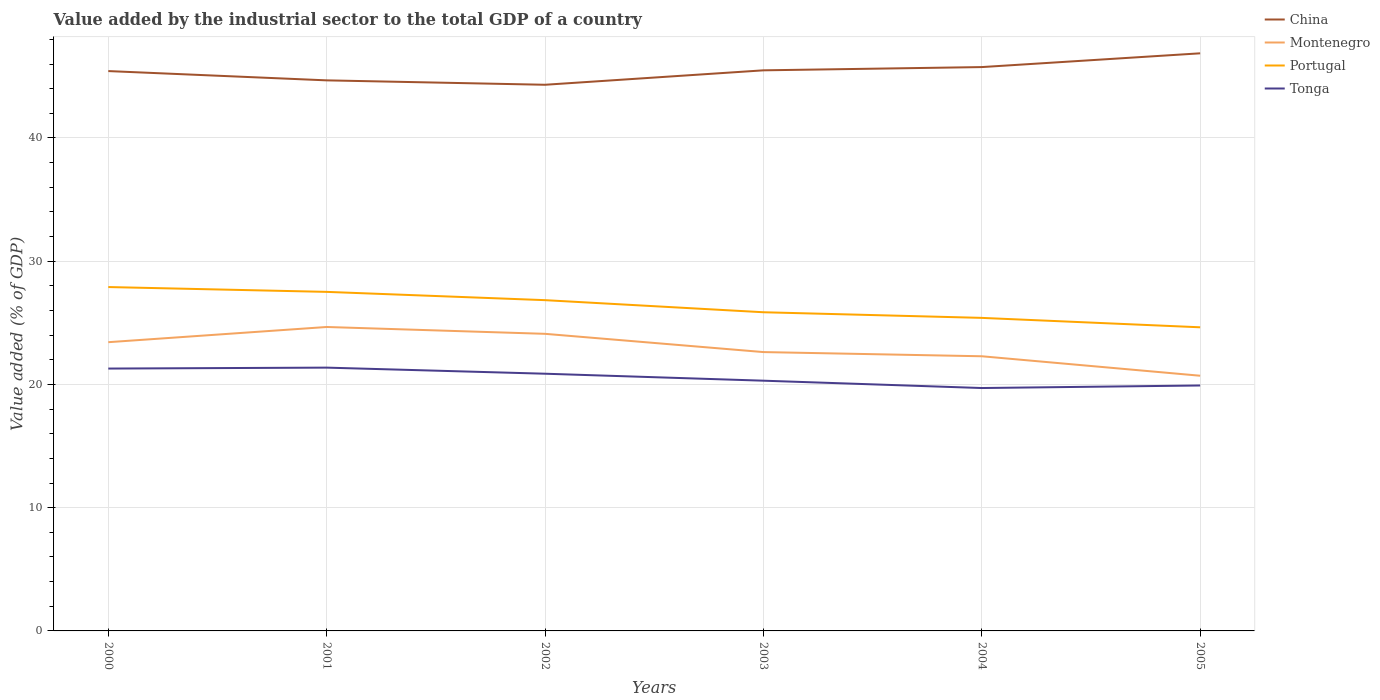Across all years, what is the maximum value added by the industrial sector to the total GDP in Montenegro?
Make the answer very short. 20.71. What is the total value added by the industrial sector to the total GDP in Montenegro in the graph?
Provide a succinct answer. 1.14. What is the difference between the highest and the second highest value added by the industrial sector to the total GDP in Portugal?
Your answer should be very brief. 3.27. What is the difference between the highest and the lowest value added by the industrial sector to the total GDP in Portugal?
Ensure brevity in your answer.  3. Is the value added by the industrial sector to the total GDP in China strictly greater than the value added by the industrial sector to the total GDP in Tonga over the years?
Give a very brief answer. No. How many years are there in the graph?
Your answer should be compact. 6. What is the difference between two consecutive major ticks on the Y-axis?
Provide a short and direct response. 10. Are the values on the major ticks of Y-axis written in scientific E-notation?
Offer a terse response. No. Does the graph contain any zero values?
Provide a short and direct response. No. How are the legend labels stacked?
Your response must be concise. Vertical. What is the title of the graph?
Offer a terse response. Value added by the industrial sector to the total GDP of a country. What is the label or title of the X-axis?
Make the answer very short. Years. What is the label or title of the Y-axis?
Keep it short and to the point. Value added (% of GDP). What is the Value added (% of GDP) of China in 2000?
Offer a very short reply. 45.43. What is the Value added (% of GDP) of Montenegro in 2000?
Your answer should be compact. 23.43. What is the Value added (% of GDP) of Portugal in 2000?
Keep it short and to the point. 27.9. What is the Value added (% of GDP) of Tonga in 2000?
Ensure brevity in your answer.  21.29. What is the Value added (% of GDP) in China in 2001?
Your answer should be very brief. 44.67. What is the Value added (% of GDP) in Montenegro in 2001?
Make the answer very short. 24.66. What is the Value added (% of GDP) in Portugal in 2001?
Offer a terse response. 27.51. What is the Value added (% of GDP) of Tonga in 2001?
Keep it short and to the point. 21.36. What is the Value added (% of GDP) in China in 2002?
Keep it short and to the point. 44.32. What is the Value added (% of GDP) in Montenegro in 2002?
Offer a terse response. 24.11. What is the Value added (% of GDP) of Portugal in 2002?
Provide a succinct answer. 26.84. What is the Value added (% of GDP) in Tonga in 2002?
Provide a short and direct response. 20.87. What is the Value added (% of GDP) in China in 2003?
Your answer should be compact. 45.49. What is the Value added (% of GDP) of Montenegro in 2003?
Provide a short and direct response. 22.63. What is the Value added (% of GDP) in Portugal in 2003?
Your answer should be very brief. 25.86. What is the Value added (% of GDP) of Tonga in 2003?
Make the answer very short. 20.3. What is the Value added (% of GDP) of China in 2004?
Your response must be concise. 45.75. What is the Value added (% of GDP) in Montenegro in 2004?
Keep it short and to the point. 22.29. What is the Value added (% of GDP) of Portugal in 2004?
Ensure brevity in your answer.  25.4. What is the Value added (% of GDP) in Tonga in 2004?
Ensure brevity in your answer.  19.71. What is the Value added (% of GDP) of China in 2005?
Your answer should be very brief. 46.87. What is the Value added (% of GDP) of Montenegro in 2005?
Offer a very short reply. 20.71. What is the Value added (% of GDP) of Portugal in 2005?
Provide a succinct answer. 24.64. What is the Value added (% of GDP) of Tonga in 2005?
Keep it short and to the point. 19.92. Across all years, what is the maximum Value added (% of GDP) of China?
Your answer should be compact. 46.87. Across all years, what is the maximum Value added (% of GDP) in Montenegro?
Your answer should be very brief. 24.66. Across all years, what is the maximum Value added (% of GDP) in Portugal?
Your answer should be very brief. 27.9. Across all years, what is the maximum Value added (% of GDP) in Tonga?
Your answer should be compact. 21.36. Across all years, what is the minimum Value added (% of GDP) in China?
Make the answer very short. 44.32. Across all years, what is the minimum Value added (% of GDP) in Montenegro?
Provide a short and direct response. 20.71. Across all years, what is the minimum Value added (% of GDP) of Portugal?
Your answer should be compact. 24.64. Across all years, what is the minimum Value added (% of GDP) of Tonga?
Ensure brevity in your answer.  19.71. What is the total Value added (% of GDP) of China in the graph?
Provide a short and direct response. 272.53. What is the total Value added (% of GDP) in Montenegro in the graph?
Ensure brevity in your answer.  137.82. What is the total Value added (% of GDP) in Portugal in the graph?
Provide a succinct answer. 158.15. What is the total Value added (% of GDP) in Tonga in the graph?
Your answer should be compact. 123.45. What is the difference between the Value added (% of GDP) of China in 2000 and that in 2001?
Your answer should be compact. 0.75. What is the difference between the Value added (% of GDP) in Montenegro in 2000 and that in 2001?
Your answer should be compact. -1.23. What is the difference between the Value added (% of GDP) in Portugal in 2000 and that in 2001?
Your response must be concise. 0.39. What is the difference between the Value added (% of GDP) in Tonga in 2000 and that in 2001?
Provide a succinct answer. -0.08. What is the difference between the Value added (% of GDP) in China in 2000 and that in 2002?
Provide a succinct answer. 1.11. What is the difference between the Value added (% of GDP) of Montenegro in 2000 and that in 2002?
Provide a succinct answer. -0.68. What is the difference between the Value added (% of GDP) of Portugal in 2000 and that in 2002?
Your answer should be compact. 1.06. What is the difference between the Value added (% of GDP) of Tonga in 2000 and that in 2002?
Keep it short and to the point. 0.42. What is the difference between the Value added (% of GDP) in China in 2000 and that in 2003?
Keep it short and to the point. -0.06. What is the difference between the Value added (% of GDP) in Montenegro in 2000 and that in 2003?
Make the answer very short. 0.8. What is the difference between the Value added (% of GDP) of Portugal in 2000 and that in 2003?
Your answer should be compact. 2.04. What is the difference between the Value added (% of GDP) of Tonga in 2000 and that in 2003?
Your answer should be compact. 0.98. What is the difference between the Value added (% of GDP) in China in 2000 and that in 2004?
Keep it short and to the point. -0.32. What is the difference between the Value added (% of GDP) in Montenegro in 2000 and that in 2004?
Give a very brief answer. 1.14. What is the difference between the Value added (% of GDP) in Portugal in 2000 and that in 2004?
Provide a succinct answer. 2.5. What is the difference between the Value added (% of GDP) in Tonga in 2000 and that in 2004?
Your answer should be very brief. 1.58. What is the difference between the Value added (% of GDP) of China in 2000 and that in 2005?
Offer a very short reply. -1.44. What is the difference between the Value added (% of GDP) of Montenegro in 2000 and that in 2005?
Your answer should be very brief. 2.72. What is the difference between the Value added (% of GDP) in Portugal in 2000 and that in 2005?
Your response must be concise. 3.27. What is the difference between the Value added (% of GDP) in Tonga in 2000 and that in 2005?
Your answer should be very brief. 1.37. What is the difference between the Value added (% of GDP) in China in 2001 and that in 2002?
Make the answer very short. 0.36. What is the difference between the Value added (% of GDP) in Montenegro in 2001 and that in 2002?
Keep it short and to the point. 0.56. What is the difference between the Value added (% of GDP) in Portugal in 2001 and that in 2002?
Give a very brief answer. 0.67. What is the difference between the Value added (% of GDP) of Tonga in 2001 and that in 2002?
Make the answer very short. 0.49. What is the difference between the Value added (% of GDP) of China in 2001 and that in 2003?
Give a very brief answer. -0.81. What is the difference between the Value added (% of GDP) in Montenegro in 2001 and that in 2003?
Your answer should be very brief. 2.04. What is the difference between the Value added (% of GDP) of Portugal in 2001 and that in 2003?
Your response must be concise. 1.65. What is the difference between the Value added (% of GDP) of Tonga in 2001 and that in 2003?
Give a very brief answer. 1.06. What is the difference between the Value added (% of GDP) in China in 2001 and that in 2004?
Your response must be concise. -1.08. What is the difference between the Value added (% of GDP) in Montenegro in 2001 and that in 2004?
Provide a short and direct response. 2.38. What is the difference between the Value added (% of GDP) in Portugal in 2001 and that in 2004?
Offer a terse response. 2.11. What is the difference between the Value added (% of GDP) of Tonga in 2001 and that in 2004?
Offer a terse response. 1.66. What is the difference between the Value added (% of GDP) in China in 2001 and that in 2005?
Give a very brief answer. -2.2. What is the difference between the Value added (% of GDP) of Montenegro in 2001 and that in 2005?
Your answer should be very brief. 3.96. What is the difference between the Value added (% of GDP) of Portugal in 2001 and that in 2005?
Your answer should be very brief. 2.87. What is the difference between the Value added (% of GDP) of Tonga in 2001 and that in 2005?
Ensure brevity in your answer.  1.45. What is the difference between the Value added (% of GDP) in China in 2002 and that in 2003?
Offer a very short reply. -1.17. What is the difference between the Value added (% of GDP) of Montenegro in 2002 and that in 2003?
Make the answer very short. 1.48. What is the difference between the Value added (% of GDP) in Portugal in 2002 and that in 2003?
Provide a short and direct response. 0.98. What is the difference between the Value added (% of GDP) in Tonga in 2002 and that in 2003?
Make the answer very short. 0.57. What is the difference between the Value added (% of GDP) of China in 2002 and that in 2004?
Give a very brief answer. -1.43. What is the difference between the Value added (% of GDP) of Montenegro in 2002 and that in 2004?
Provide a succinct answer. 1.82. What is the difference between the Value added (% of GDP) in Portugal in 2002 and that in 2004?
Offer a very short reply. 1.44. What is the difference between the Value added (% of GDP) in Tonga in 2002 and that in 2004?
Keep it short and to the point. 1.16. What is the difference between the Value added (% of GDP) of China in 2002 and that in 2005?
Your answer should be compact. -2.55. What is the difference between the Value added (% of GDP) in Montenegro in 2002 and that in 2005?
Provide a succinct answer. 3.4. What is the difference between the Value added (% of GDP) of Portugal in 2002 and that in 2005?
Your response must be concise. 2.2. What is the difference between the Value added (% of GDP) of Tonga in 2002 and that in 2005?
Keep it short and to the point. 0.95. What is the difference between the Value added (% of GDP) of China in 2003 and that in 2004?
Offer a very short reply. -0.26. What is the difference between the Value added (% of GDP) of Montenegro in 2003 and that in 2004?
Provide a short and direct response. 0.34. What is the difference between the Value added (% of GDP) in Portugal in 2003 and that in 2004?
Your answer should be very brief. 0.46. What is the difference between the Value added (% of GDP) of Tonga in 2003 and that in 2004?
Provide a succinct answer. 0.6. What is the difference between the Value added (% of GDP) of China in 2003 and that in 2005?
Offer a very short reply. -1.38. What is the difference between the Value added (% of GDP) of Montenegro in 2003 and that in 2005?
Your answer should be compact. 1.92. What is the difference between the Value added (% of GDP) in Portugal in 2003 and that in 2005?
Offer a very short reply. 1.22. What is the difference between the Value added (% of GDP) of Tonga in 2003 and that in 2005?
Make the answer very short. 0.39. What is the difference between the Value added (% of GDP) in China in 2004 and that in 2005?
Your response must be concise. -1.12. What is the difference between the Value added (% of GDP) in Montenegro in 2004 and that in 2005?
Your answer should be compact. 1.58. What is the difference between the Value added (% of GDP) in Portugal in 2004 and that in 2005?
Provide a succinct answer. 0.76. What is the difference between the Value added (% of GDP) in Tonga in 2004 and that in 2005?
Keep it short and to the point. -0.21. What is the difference between the Value added (% of GDP) of China in 2000 and the Value added (% of GDP) of Montenegro in 2001?
Ensure brevity in your answer.  20.77. What is the difference between the Value added (% of GDP) of China in 2000 and the Value added (% of GDP) of Portugal in 2001?
Your response must be concise. 17.92. What is the difference between the Value added (% of GDP) of China in 2000 and the Value added (% of GDP) of Tonga in 2001?
Provide a short and direct response. 24.06. What is the difference between the Value added (% of GDP) of Montenegro in 2000 and the Value added (% of GDP) of Portugal in 2001?
Offer a very short reply. -4.08. What is the difference between the Value added (% of GDP) in Montenegro in 2000 and the Value added (% of GDP) in Tonga in 2001?
Your answer should be compact. 2.06. What is the difference between the Value added (% of GDP) in Portugal in 2000 and the Value added (% of GDP) in Tonga in 2001?
Your answer should be compact. 6.54. What is the difference between the Value added (% of GDP) of China in 2000 and the Value added (% of GDP) of Montenegro in 2002?
Keep it short and to the point. 21.32. What is the difference between the Value added (% of GDP) in China in 2000 and the Value added (% of GDP) in Portugal in 2002?
Keep it short and to the point. 18.59. What is the difference between the Value added (% of GDP) of China in 2000 and the Value added (% of GDP) of Tonga in 2002?
Keep it short and to the point. 24.56. What is the difference between the Value added (% of GDP) of Montenegro in 2000 and the Value added (% of GDP) of Portugal in 2002?
Offer a terse response. -3.41. What is the difference between the Value added (% of GDP) in Montenegro in 2000 and the Value added (% of GDP) in Tonga in 2002?
Give a very brief answer. 2.56. What is the difference between the Value added (% of GDP) of Portugal in 2000 and the Value added (% of GDP) of Tonga in 2002?
Your answer should be compact. 7.03. What is the difference between the Value added (% of GDP) of China in 2000 and the Value added (% of GDP) of Montenegro in 2003?
Offer a very short reply. 22.8. What is the difference between the Value added (% of GDP) of China in 2000 and the Value added (% of GDP) of Portugal in 2003?
Your response must be concise. 19.57. What is the difference between the Value added (% of GDP) of China in 2000 and the Value added (% of GDP) of Tonga in 2003?
Offer a terse response. 25.12. What is the difference between the Value added (% of GDP) of Montenegro in 2000 and the Value added (% of GDP) of Portugal in 2003?
Ensure brevity in your answer.  -2.43. What is the difference between the Value added (% of GDP) of Montenegro in 2000 and the Value added (% of GDP) of Tonga in 2003?
Ensure brevity in your answer.  3.12. What is the difference between the Value added (% of GDP) in Portugal in 2000 and the Value added (% of GDP) in Tonga in 2003?
Offer a terse response. 7.6. What is the difference between the Value added (% of GDP) in China in 2000 and the Value added (% of GDP) in Montenegro in 2004?
Your answer should be very brief. 23.14. What is the difference between the Value added (% of GDP) of China in 2000 and the Value added (% of GDP) of Portugal in 2004?
Give a very brief answer. 20.03. What is the difference between the Value added (% of GDP) in China in 2000 and the Value added (% of GDP) in Tonga in 2004?
Offer a terse response. 25.72. What is the difference between the Value added (% of GDP) in Montenegro in 2000 and the Value added (% of GDP) in Portugal in 2004?
Give a very brief answer. -1.97. What is the difference between the Value added (% of GDP) in Montenegro in 2000 and the Value added (% of GDP) in Tonga in 2004?
Offer a terse response. 3.72. What is the difference between the Value added (% of GDP) in Portugal in 2000 and the Value added (% of GDP) in Tonga in 2004?
Provide a short and direct response. 8.19. What is the difference between the Value added (% of GDP) of China in 2000 and the Value added (% of GDP) of Montenegro in 2005?
Offer a terse response. 24.72. What is the difference between the Value added (% of GDP) of China in 2000 and the Value added (% of GDP) of Portugal in 2005?
Ensure brevity in your answer.  20.79. What is the difference between the Value added (% of GDP) in China in 2000 and the Value added (% of GDP) in Tonga in 2005?
Provide a succinct answer. 25.51. What is the difference between the Value added (% of GDP) of Montenegro in 2000 and the Value added (% of GDP) of Portugal in 2005?
Your answer should be very brief. -1.21. What is the difference between the Value added (% of GDP) of Montenegro in 2000 and the Value added (% of GDP) of Tonga in 2005?
Offer a terse response. 3.51. What is the difference between the Value added (% of GDP) of Portugal in 2000 and the Value added (% of GDP) of Tonga in 2005?
Provide a short and direct response. 7.99. What is the difference between the Value added (% of GDP) in China in 2001 and the Value added (% of GDP) in Montenegro in 2002?
Your response must be concise. 20.57. What is the difference between the Value added (% of GDP) in China in 2001 and the Value added (% of GDP) in Portugal in 2002?
Keep it short and to the point. 17.84. What is the difference between the Value added (% of GDP) of China in 2001 and the Value added (% of GDP) of Tonga in 2002?
Offer a terse response. 23.8. What is the difference between the Value added (% of GDP) of Montenegro in 2001 and the Value added (% of GDP) of Portugal in 2002?
Your response must be concise. -2.18. What is the difference between the Value added (% of GDP) of Montenegro in 2001 and the Value added (% of GDP) of Tonga in 2002?
Ensure brevity in your answer.  3.79. What is the difference between the Value added (% of GDP) of Portugal in 2001 and the Value added (% of GDP) of Tonga in 2002?
Offer a terse response. 6.64. What is the difference between the Value added (% of GDP) in China in 2001 and the Value added (% of GDP) in Montenegro in 2003?
Offer a terse response. 22.05. What is the difference between the Value added (% of GDP) in China in 2001 and the Value added (% of GDP) in Portugal in 2003?
Make the answer very short. 18.82. What is the difference between the Value added (% of GDP) of China in 2001 and the Value added (% of GDP) of Tonga in 2003?
Your response must be concise. 24.37. What is the difference between the Value added (% of GDP) of Montenegro in 2001 and the Value added (% of GDP) of Portugal in 2003?
Offer a very short reply. -1.2. What is the difference between the Value added (% of GDP) of Montenegro in 2001 and the Value added (% of GDP) of Tonga in 2003?
Ensure brevity in your answer.  4.36. What is the difference between the Value added (% of GDP) in Portugal in 2001 and the Value added (% of GDP) in Tonga in 2003?
Your answer should be compact. 7.21. What is the difference between the Value added (% of GDP) in China in 2001 and the Value added (% of GDP) in Montenegro in 2004?
Give a very brief answer. 22.39. What is the difference between the Value added (% of GDP) in China in 2001 and the Value added (% of GDP) in Portugal in 2004?
Provide a succinct answer. 19.27. What is the difference between the Value added (% of GDP) in China in 2001 and the Value added (% of GDP) in Tonga in 2004?
Keep it short and to the point. 24.97. What is the difference between the Value added (% of GDP) in Montenegro in 2001 and the Value added (% of GDP) in Portugal in 2004?
Offer a very short reply. -0.74. What is the difference between the Value added (% of GDP) of Montenegro in 2001 and the Value added (% of GDP) of Tonga in 2004?
Keep it short and to the point. 4.95. What is the difference between the Value added (% of GDP) of Portugal in 2001 and the Value added (% of GDP) of Tonga in 2004?
Provide a short and direct response. 7.8. What is the difference between the Value added (% of GDP) in China in 2001 and the Value added (% of GDP) in Montenegro in 2005?
Provide a short and direct response. 23.97. What is the difference between the Value added (% of GDP) of China in 2001 and the Value added (% of GDP) of Portugal in 2005?
Provide a succinct answer. 20.04. What is the difference between the Value added (% of GDP) of China in 2001 and the Value added (% of GDP) of Tonga in 2005?
Ensure brevity in your answer.  24.76. What is the difference between the Value added (% of GDP) in Montenegro in 2001 and the Value added (% of GDP) in Portugal in 2005?
Your response must be concise. 0.03. What is the difference between the Value added (% of GDP) in Montenegro in 2001 and the Value added (% of GDP) in Tonga in 2005?
Make the answer very short. 4.75. What is the difference between the Value added (% of GDP) of Portugal in 2001 and the Value added (% of GDP) of Tonga in 2005?
Your response must be concise. 7.6. What is the difference between the Value added (% of GDP) in China in 2002 and the Value added (% of GDP) in Montenegro in 2003?
Provide a short and direct response. 21.69. What is the difference between the Value added (% of GDP) of China in 2002 and the Value added (% of GDP) of Portugal in 2003?
Give a very brief answer. 18.46. What is the difference between the Value added (% of GDP) of China in 2002 and the Value added (% of GDP) of Tonga in 2003?
Offer a terse response. 24.01. What is the difference between the Value added (% of GDP) in Montenegro in 2002 and the Value added (% of GDP) in Portugal in 2003?
Keep it short and to the point. -1.75. What is the difference between the Value added (% of GDP) of Montenegro in 2002 and the Value added (% of GDP) of Tonga in 2003?
Your answer should be compact. 3.8. What is the difference between the Value added (% of GDP) of Portugal in 2002 and the Value added (% of GDP) of Tonga in 2003?
Give a very brief answer. 6.53. What is the difference between the Value added (% of GDP) of China in 2002 and the Value added (% of GDP) of Montenegro in 2004?
Provide a succinct answer. 22.03. What is the difference between the Value added (% of GDP) of China in 2002 and the Value added (% of GDP) of Portugal in 2004?
Give a very brief answer. 18.92. What is the difference between the Value added (% of GDP) in China in 2002 and the Value added (% of GDP) in Tonga in 2004?
Keep it short and to the point. 24.61. What is the difference between the Value added (% of GDP) of Montenegro in 2002 and the Value added (% of GDP) of Portugal in 2004?
Offer a very short reply. -1.29. What is the difference between the Value added (% of GDP) in Montenegro in 2002 and the Value added (% of GDP) in Tonga in 2004?
Your answer should be compact. 4.4. What is the difference between the Value added (% of GDP) in Portugal in 2002 and the Value added (% of GDP) in Tonga in 2004?
Make the answer very short. 7.13. What is the difference between the Value added (% of GDP) of China in 2002 and the Value added (% of GDP) of Montenegro in 2005?
Your response must be concise. 23.61. What is the difference between the Value added (% of GDP) of China in 2002 and the Value added (% of GDP) of Portugal in 2005?
Provide a succinct answer. 19.68. What is the difference between the Value added (% of GDP) in China in 2002 and the Value added (% of GDP) in Tonga in 2005?
Give a very brief answer. 24.4. What is the difference between the Value added (% of GDP) in Montenegro in 2002 and the Value added (% of GDP) in Portugal in 2005?
Provide a short and direct response. -0.53. What is the difference between the Value added (% of GDP) in Montenegro in 2002 and the Value added (% of GDP) in Tonga in 2005?
Your answer should be compact. 4.19. What is the difference between the Value added (% of GDP) in Portugal in 2002 and the Value added (% of GDP) in Tonga in 2005?
Ensure brevity in your answer.  6.92. What is the difference between the Value added (% of GDP) of China in 2003 and the Value added (% of GDP) of Montenegro in 2004?
Ensure brevity in your answer.  23.2. What is the difference between the Value added (% of GDP) of China in 2003 and the Value added (% of GDP) of Portugal in 2004?
Offer a terse response. 20.09. What is the difference between the Value added (% of GDP) in China in 2003 and the Value added (% of GDP) in Tonga in 2004?
Give a very brief answer. 25.78. What is the difference between the Value added (% of GDP) of Montenegro in 2003 and the Value added (% of GDP) of Portugal in 2004?
Your answer should be very brief. -2.77. What is the difference between the Value added (% of GDP) in Montenegro in 2003 and the Value added (% of GDP) in Tonga in 2004?
Offer a very short reply. 2.92. What is the difference between the Value added (% of GDP) in Portugal in 2003 and the Value added (% of GDP) in Tonga in 2004?
Provide a succinct answer. 6.15. What is the difference between the Value added (% of GDP) of China in 2003 and the Value added (% of GDP) of Montenegro in 2005?
Give a very brief answer. 24.78. What is the difference between the Value added (% of GDP) of China in 2003 and the Value added (% of GDP) of Portugal in 2005?
Make the answer very short. 20.85. What is the difference between the Value added (% of GDP) of China in 2003 and the Value added (% of GDP) of Tonga in 2005?
Provide a succinct answer. 25.57. What is the difference between the Value added (% of GDP) of Montenegro in 2003 and the Value added (% of GDP) of Portugal in 2005?
Give a very brief answer. -2.01. What is the difference between the Value added (% of GDP) in Montenegro in 2003 and the Value added (% of GDP) in Tonga in 2005?
Ensure brevity in your answer.  2.71. What is the difference between the Value added (% of GDP) in Portugal in 2003 and the Value added (% of GDP) in Tonga in 2005?
Keep it short and to the point. 5.94. What is the difference between the Value added (% of GDP) in China in 2004 and the Value added (% of GDP) in Montenegro in 2005?
Your answer should be very brief. 25.05. What is the difference between the Value added (% of GDP) in China in 2004 and the Value added (% of GDP) in Portugal in 2005?
Ensure brevity in your answer.  21.12. What is the difference between the Value added (% of GDP) of China in 2004 and the Value added (% of GDP) of Tonga in 2005?
Make the answer very short. 25.84. What is the difference between the Value added (% of GDP) in Montenegro in 2004 and the Value added (% of GDP) in Portugal in 2005?
Give a very brief answer. -2.35. What is the difference between the Value added (% of GDP) of Montenegro in 2004 and the Value added (% of GDP) of Tonga in 2005?
Keep it short and to the point. 2.37. What is the difference between the Value added (% of GDP) in Portugal in 2004 and the Value added (% of GDP) in Tonga in 2005?
Provide a short and direct response. 5.49. What is the average Value added (% of GDP) of China per year?
Offer a very short reply. 45.42. What is the average Value added (% of GDP) in Montenegro per year?
Your answer should be very brief. 22.97. What is the average Value added (% of GDP) of Portugal per year?
Provide a succinct answer. 26.36. What is the average Value added (% of GDP) of Tonga per year?
Make the answer very short. 20.58. In the year 2000, what is the difference between the Value added (% of GDP) in China and Value added (% of GDP) in Montenegro?
Offer a terse response. 22. In the year 2000, what is the difference between the Value added (% of GDP) of China and Value added (% of GDP) of Portugal?
Provide a short and direct response. 17.52. In the year 2000, what is the difference between the Value added (% of GDP) in China and Value added (% of GDP) in Tonga?
Provide a short and direct response. 24.14. In the year 2000, what is the difference between the Value added (% of GDP) in Montenegro and Value added (% of GDP) in Portugal?
Provide a short and direct response. -4.47. In the year 2000, what is the difference between the Value added (% of GDP) of Montenegro and Value added (% of GDP) of Tonga?
Your answer should be very brief. 2.14. In the year 2000, what is the difference between the Value added (% of GDP) in Portugal and Value added (% of GDP) in Tonga?
Provide a succinct answer. 6.61. In the year 2001, what is the difference between the Value added (% of GDP) in China and Value added (% of GDP) in Montenegro?
Give a very brief answer. 20.01. In the year 2001, what is the difference between the Value added (% of GDP) in China and Value added (% of GDP) in Portugal?
Offer a terse response. 17.16. In the year 2001, what is the difference between the Value added (% of GDP) in China and Value added (% of GDP) in Tonga?
Your answer should be very brief. 23.31. In the year 2001, what is the difference between the Value added (% of GDP) of Montenegro and Value added (% of GDP) of Portugal?
Provide a succinct answer. -2.85. In the year 2001, what is the difference between the Value added (% of GDP) in Montenegro and Value added (% of GDP) in Tonga?
Provide a short and direct response. 3.3. In the year 2001, what is the difference between the Value added (% of GDP) in Portugal and Value added (% of GDP) in Tonga?
Your response must be concise. 6.15. In the year 2002, what is the difference between the Value added (% of GDP) of China and Value added (% of GDP) of Montenegro?
Your response must be concise. 20.21. In the year 2002, what is the difference between the Value added (% of GDP) in China and Value added (% of GDP) in Portugal?
Give a very brief answer. 17.48. In the year 2002, what is the difference between the Value added (% of GDP) in China and Value added (% of GDP) in Tonga?
Provide a short and direct response. 23.45. In the year 2002, what is the difference between the Value added (% of GDP) in Montenegro and Value added (% of GDP) in Portugal?
Your answer should be very brief. -2.73. In the year 2002, what is the difference between the Value added (% of GDP) of Montenegro and Value added (% of GDP) of Tonga?
Your response must be concise. 3.24. In the year 2002, what is the difference between the Value added (% of GDP) of Portugal and Value added (% of GDP) of Tonga?
Give a very brief answer. 5.97. In the year 2003, what is the difference between the Value added (% of GDP) of China and Value added (% of GDP) of Montenegro?
Keep it short and to the point. 22.86. In the year 2003, what is the difference between the Value added (% of GDP) of China and Value added (% of GDP) of Portugal?
Offer a terse response. 19.63. In the year 2003, what is the difference between the Value added (% of GDP) in China and Value added (% of GDP) in Tonga?
Your response must be concise. 25.18. In the year 2003, what is the difference between the Value added (% of GDP) in Montenegro and Value added (% of GDP) in Portugal?
Keep it short and to the point. -3.23. In the year 2003, what is the difference between the Value added (% of GDP) in Montenegro and Value added (% of GDP) in Tonga?
Give a very brief answer. 2.32. In the year 2003, what is the difference between the Value added (% of GDP) of Portugal and Value added (% of GDP) of Tonga?
Make the answer very short. 5.55. In the year 2004, what is the difference between the Value added (% of GDP) in China and Value added (% of GDP) in Montenegro?
Ensure brevity in your answer.  23.47. In the year 2004, what is the difference between the Value added (% of GDP) in China and Value added (% of GDP) in Portugal?
Your response must be concise. 20.35. In the year 2004, what is the difference between the Value added (% of GDP) of China and Value added (% of GDP) of Tonga?
Your answer should be compact. 26.04. In the year 2004, what is the difference between the Value added (% of GDP) of Montenegro and Value added (% of GDP) of Portugal?
Keep it short and to the point. -3.11. In the year 2004, what is the difference between the Value added (% of GDP) in Montenegro and Value added (% of GDP) in Tonga?
Offer a terse response. 2.58. In the year 2004, what is the difference between the Value added (% of GDP) in Portugal and Value added (% of GDP) in Tonga?
Provide a short and direct response. 5.69. In the year 2005, what is the difference between the Value added (% of GDP) of China and Value added (% of GDP) of Montenegro?
Your response must be concise. 26.16. In the year 2005, what is the difference between the Value added (% of GDP) in China and Value added (% of GDP) in Portugal?
Offer a terse response. 22.23. In the year 2005, what is the difference between the Value added (% of GDP) in China and Value added (% of GDP) in Tonga?
Ensure brevity in your answer.  26.95. In the year 2005, what is the difference between the Value added (% of GDP) of Montenegro and Value added (% of GDP) of Portugal?
Your response must be concise. -3.93. In the year 2005, what is the difference between the Value added (% of GDP) of Montenegro and Value added (% of GDP) of Tonga?
Ensure brevity in your answer.  0.79. In the year 2005, what is the difference between the Value added (% of GDP) in Portugal and Value added (% of GDP) in Tonga?
Keep it short and to the point. 4.72. What is the ratio of the Value added (% of GDP) in China in 2000 to that in 2001?
Your response must be concise. 1.02. What is the ratio of the Value added (% of GDP) in Portugal in 2000 to that in 2001?
Make the answer very short. 1.01. What is the ratio of the Value added (% of GDP) in Tonga in 2000 to that in 2001?
Provide a short and direct response. 1. What is the ratio of the Value added (% of GDP) of China in 2000 to that in 2002?
Provide a succinct answer. 1.03. What is the ratio of the Value added (% of GDP) in Montenegro in 2000 to that in 2002?
Your answer should be compact. 0.97. What is the ratio of the Value added (% of GDP) in Portugal in 2000 to that in 2002?
Ensure brevity in your answer.  1.04. What is the ratio of the Value added (% of GDP) in Montenegro in 2000 to that in 2003?
Provide a short and direct response. 1.04. What is the ratio of the Value added (% of GDP) of Portugal in 2000 to that in 2003?
Offer a terse response. 1.08. What is the ratio of the Value added (% of GDP) in Tonga in 2000 to that in 2003?
Ensure brevity in your answer.  1.05. What is the ratio of the Value added (% of GDP) in Montenegro in 2000 to that in 2004?
Your answer should be very brief. 1.05. What is the ratio of the Value added (% of GDP) in Portugal in 2000 to that in 2004?
Ensure brevity in your answer.  1.1. What is the ratio of the Value added (% of GDP) of Tonga in 2000 to that in 2004?
Keep it short and to the point. 1.08. What is the ratio of the Value added (% of GDP) of China in 2000 to that in 2005?
Your answer should be compact. 0.97. What is the ratio of the Value added (% of GDP) of Montenegro in 2000 to that in 2005?
Keep it short and to the point. 1.13. What is the ratio of the Value added (% of GDP) of Portugal in 2000 to that in 2005?
Your answer should be compact. 1.13. What is the ratio of the Value added (% of GDP) in Tonga in 2000 to that in 2005?
Provide a succinct answer. 1.07. What is the ratio of the Value added (% of GDP) of Portugal in 2001 to that in 2002?
Make the answer very short. 1.03. What is the ratio of the Value added (% of GDP) of Tonga in 2001 to that in 2002?
Your answer should be very brief. 1.02. What is the ratio of the Value added (% of GDP) in China in 2001 to that in 2003?
Your response must be concise. 0.98. What is the ratio of the Value added (% of GDP) of Montenegro in 2001 to that in 2003?
Give a very brief answer. 1.09. What is the ratio of the Value added (% of GDP) in Portugal in 2001 to that in 2003?
Your answer should be compact. 1.06. What is the ratio of the Value added (% of GDP) in Tonga in 2001 to that in 2003?
Keep it short and to the point. 1.05. What is the ratio of the Value added (% of GDP) in China in 2001 to that in 2004?
Provide a succinct answer. 0.98. What is the ratio of the Value added (% of GDP) of Montenegro in 2001 to that in 2004?
Offer a terse response. 1.11. What is the ratio of the Value added (% of GDP) in Portugal in 2001 to that in 2004?
Your answer should be compact. 1.08. What is the ratio of the Value added (% of GDP) in Tonga in 2001 to that in 2004?
Offer a very short reply. 1.08. What is the ratio of the Value added (% of GDP) in China in 2001 to that in 2005?
Provide a short and direct response. 0.95. What is the ratio of the Value added (% of GDP) in Montenegro in 2001 to that in 2005?
Ensure brevity in your answer.  1.19. What is the ratio of the Value added (% of GDP) of Portugal in 2001 to that in 2005?
Provide a short and direct response. 1.12. What is the ratio of the Value added (% of GDP) of Tonga in 2001 to that in 2005?
Your response must be concise. 1.07. What is the ratio of the Value added (% of GDP) in China in 2002 to that in 2003?
Offer a terse response. 0.97. What is the ratio of the Value added (% of GDP) of Montenegro in 2002 to that in 2003?
Your answer should be compact. 1.07. What is the ratio of the Value added (% of GDP) in Portugal in 2002 to that in 2003?
Give a very brief answer. 1.04. What is the ratio of the Value added (% of GDP) of Tonga in 2002 to that in 2003?
Give a very brief answer. 1.03. What is the ratio of the Value added (% of GDP) of China in 2002 to that in 2004?
Your answer should be very brief. 0.97. What is the ratio of the Value added (% of GDP) of Montenegro in 2002 to that in 2004?
Give a very brief answer. 1.08. What is the ratio of the Value added (% of GDP) in Portugal in 2002 to that in 2004?
Make the answer very short. 1.06. What is the ratio of the Value added (% of GDP) of Tonga in 2002 to that in 2004?
Provide a short and direct response. 1.06. What is the ratio of the Value added (% of GDP) of China in 2002 to that in 2005?
Ensure brevity in your answer.  0.95. What is the ratio of the Value added (% of GDP) of Montenegro in 2002 to that in 2005?
Offer a terse response. 1.16. What is the ratio of the Value added (% of GDP) of Portugal in 2002 to that in 2005?
Make the answer very short. 1.09. What is the ratio of the Value added (% of GDP) of Tonga in 2002 to that in 2005?
Ensure brevity in your answer.  1.05. What is the ratio of the Value added (% of GDP) of Montenegro in 2003 to that in 2004?
Provide a succinct answer. 1.02. What is the ratio of the Value added (% of GDP) in Portugal in 2003 to that in 2004?
Offer a very short reply. 1.02. What is the ratio of the Value added (% of GDP) of Tonga in 2003 to that in 2004?
Your answer should be compact. 1.03. What is the ratio of the Value added (% of GDP) in China in 2003 to that in 2005?
Provide a succinct answer. 0.97. What is the ratio of the Value added (% of GDP) in Montenegro in 2003 to that in 2005?
Keep it short and to the point. 1.09. What is the ratio of the Value added (% of GDP) of Portugal in 2003 to that in 2005?
Keep it short and to the point. 1.05. What is the ratio of the Value added (% of GDP) in Tonga in 2003 to that in 2005?
Your response must be concise. 1.02. What is the ratio of the Value added (% of GDP) of China in 2004 to that in 2005?
Give a very brief answer. 0.98. What is the ratio of the Value added (% of GDP) in Montenegro in 2004 to that in 2005?
Make the answer very short. 1.08. What is the ratio of the Value added (% of GDP) in Portugal in 2004 to that in 2005?
Make the answer very short. 1.03. What is the difference between the highest and the second highest Value added (% of GDP) of China?
Provide a succinct answer. 1.12. What is the difference between the highest and the second highest Value added (% of GDP) in Montenegro?
Keep it short and to the point. 0.56. What is the difference between the highest and the second highest Value added (% of GDP) of Portugal?
Your answer should be very brief. 0.39. What is the difference between the highest and the second highest Value added (% of GDP) in Tonga?
Ensure brevity in your answer.  0.08. What is the difference between the highest and the lowest Value added (% of GDP) in China?
Your answer should be very brief. 2.55. What is the difference between the highest and the lowest Value added (% of GDP) of Montenegro?
Provide a succinct answer. 3.96. What is the difference between the highest and the lowest Value added (% of GDP) in Portugal?
Your answer should be compact. 3.27. What is the difference between the highest and the lowest Value added (% of GDP) in Tonga?
Keep it short and to the point. 1.66. 